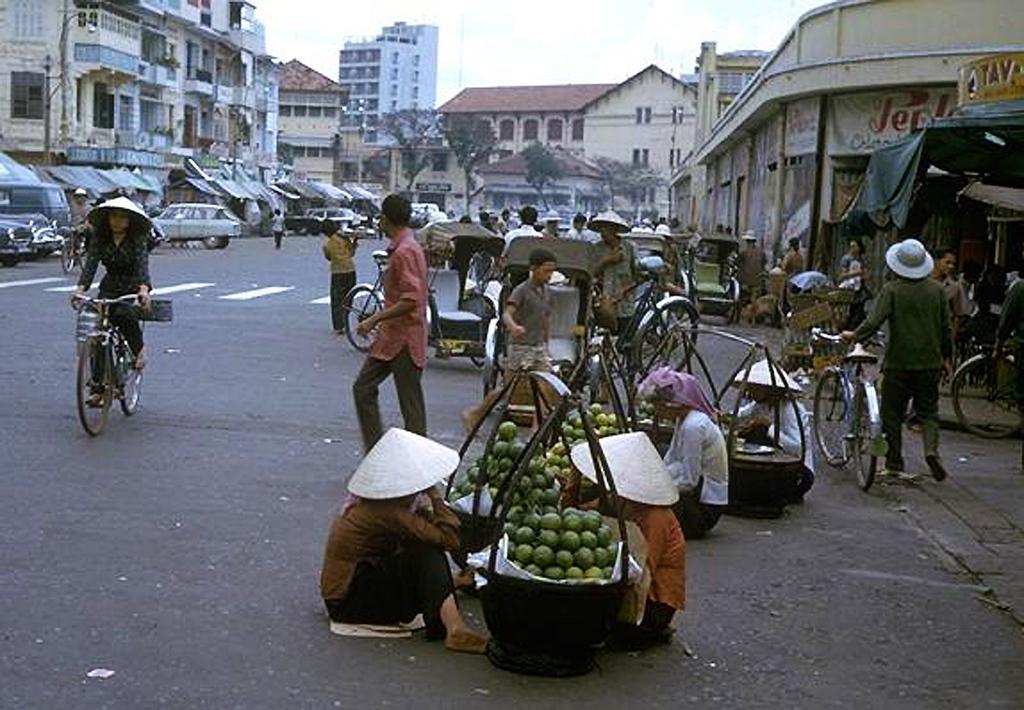Can you describe this image briefly? This is the picture of some people who are wearing hats and sitting in front of the baskets in which there are some fruits and around there are some trees, buildings, houses, vehicles and some other things around. 